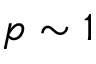<formula> <loc_0><loc_0><loc_500><loc_500>p \sim 1</formula> 